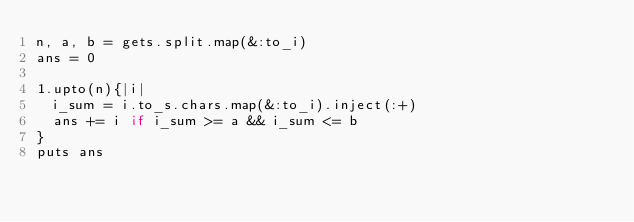Convert code to text. <code><loc_0><loc_0><loc_500><loc_500><_Ruby_>n, a, b = gets.split.map(&:to_i)
ans = 0

1.upto(n){|i|
  i_sum = i.to_s.chars.map(&:to_i).inject(:+)
  ans += i if i_sum >= a && i_sum <= b
} 
puts ans</code> 